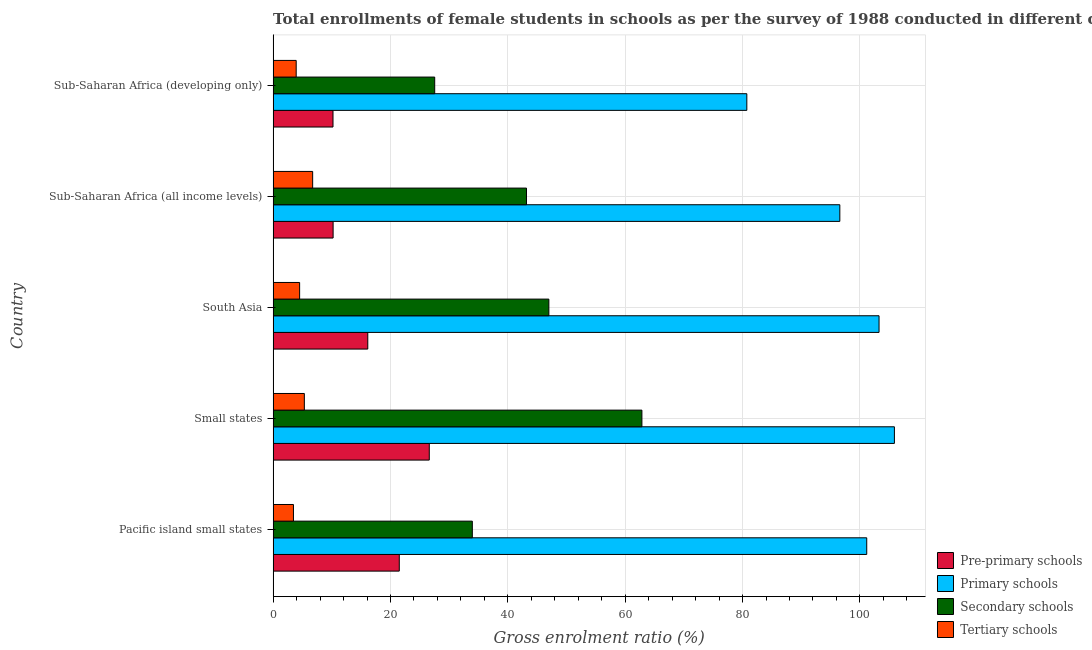How many groups of bars are there?
Your response must be concise. 5. Are the number of bars on each tick of the Y-axis equal?
Your answer should be compact. Yes. How many bars are there on the 3rd tick from the bottom?
Your answer should be compact. 4. What is the label of the 1st group of bars from the top?
Provide a succinct answer. Sub-Saharan Africa (developing only). In how many cases, is the number of bars for a given country not equal to the number of legend labels?
Provide a short and direct response. 0. What is the gross enrolment ratio(female) in secondary schools in Small states?
Your answer should be compact. 62.85. Across all countries, what is the maximum gross enrolment ratio(female) in primary schools?
Give a very brief answer. 105.88. Across all countries, what is the minimum gross enrolment ratio(female) in primary schools?
Provide a succinct answer. 80.73. In which country was the gross enrolment ratio(female) in primary schools maximum?
Your answer should be compact. Small states. In which country was the gross enrolment ratio(female) in tertiary schools minimum?
Make the answer very short. Pacific island small states. What is the total gross enrolment ratio(female) in secondary schools in the graph?
Give a very brief answer. 214.5. What is the difference between the gross enrolment ratio(female) in tertiary schools in Pacific island small states and that in South Asia?
Offer a terse response. -1.05. What is the difference between the gross enrolment ratio(female) in pre-primary schools in Small states and the gross enrolment ratio(female) in secondary schools in Sub-Saharan Africa (developing only)?
Offer a terse response. -0.92. What is the average gross enrolment ratio(female) in pre-primary schools per country?
Give a very brief answer. 16.93. What is the difference between the gross enrolment ratio(female) in pre-primary schools and gross enrolment ratio(female) in primary schools in South Asia?
Your response must be concise. -87.13. What is the ratio of the gross enrolment ratio(female) in pre-primary schools in Small states to that in South Asia?
Offer a very short reply. 1.65. Is the gross enrolment ratio(female) in primary schools in Small states less than that in Sub-Saharan Africa (all income levels)?
Your response must be concise. No. What is the difference between the highest and the second highest gross enrolment ratio(female) in primary schools?
Offer a terse response. 2.62. What is the difference between the highest and the lowest gross enrolment ratio(female) in secondary schools?
Provide a short and direct response. 35.31. In how many countries, is the gross enrolment ratio(female) in tertiary schools greater than the average gross enrolment ratio(female) in tertiary schools taken over all countries?
Keep it short and to the point. 2. Is it the case that in every country, the sum of the gross enrolment ratio(female) in pre-primary schools and gross enrolment ratio(female) in primary schools is greater than the sum of gross enrolment ratio(female) in secondary schools and gross enrolment ratio(female) in tertiary schools?
Provide a short and direct response. Yes. What does the 4th bar from the top in Sub-Saharan Africa (all income levels) represents?
Ensure brevity in your answer.  Pre-primary schools. What does the 1st bar from the bottom in Small states represents?
Offer a very short reply. Pre-primary schools. Is it the case that in every country, the sum of the gross enrolment ratio(female) in pre-primary schools and gross enrolment ratio(female) in primary schools is greater than the gross enrolment ratio(female) in secondary schools?
Ensure brevity in your answer.  Yes. Are all the bars in the graph horizontal?
Ensure brevity in your answer.  Yes. How many countries are there in the graph?
Ensure brevity in your answer.  5. What is the difference between two consecutive major ticks on the X-axis?
Your answer should be compact. 20. Are the values on the major ticks of X-axis written in scientific E-notation?
Keep it short and to the point. No. Where does the legend appear in the graph?
Make the answer very short. Bottom right. How many legend labels are there?
Provide a succinct answer. 4. What is the title of the graph?
Make the answer very short. Total enrollments of female students in schools as per the survey of 1988 conducted in different countries. Does "Management rating" appear as one of the legend labels in the graph?
Your response must be concise. No. What is the label or title of the Y-axis?
Your answer should be very brief. Country. What is the Gross enrolment ratio (%) of Pre-primary schools in Pacific island small states?
Your response must be concise. 21.5. What is the Gross enrolment ratio (%) of Primary schools in Pacific island small states?
Offer a terse response. 101.16. What is the Gross enrolment ratio (%) in Secondary schools in Pacific island small states?
Provide a short and direct response. 33.95. What is the Gross enrolment ratio (%) of Tertiary schools in Pacific island small states?
Your answer should be compact. 3.46. What is the Gross enrolment ratio (%) of Pre-primary schools in Small states?
Make the answer very short. 26.61. What is the Gross enrolment ratio (%) of Primary schools in Small states?
Make the answer very short. 105.88. What is the Gross enrolment ratio (%) in Secondary schools in Small states?
Your answer should be compact. 62.85. What is the Gross enrolment ratio (%) in Tertiary schools in Small states?
Make the answer very short. 5.32. What is the Gross enrolment ratio (%) in Pre-primary schools in South Asia?
Keep it short and to the point. 16.13. What is the Gross enrolment ratio (%) in Primary schools in South Asia?
Offer a very short reply. 103.26. What is the Gross enrolment ratio (%) in Secondary schools in South Asia?
Offer a terse response. 46.99. What is the Gross enrolment ratio (%) of Tertiary schools in South Asia?
Provide a succinct answer. 4.52. What is the Gross enrolment ratio (%) in Pre-primary schools in Sub-Saharan Africa (all income levels)?
Offer a very short reply. 10.22. What is the Gross enrolment ratio (%) of Primary schools in Sub-Saharan Africa (all income levels)?
Provide a short and direct response. 96.58. What is the Gross enrolment ratio (%) of Secondary schools in Sub-Saharan Africa (all income levels)?
Provide a short and direct response. 43.18. What is the Gross enrolment ratio (%) in Tertiary schools in Sub-Saharan Africa (all income levels)?
Provide a succinct answer. 6.74. What is the Gross enrolment ratio (%) in Pre-primary schools in Sub-Saharan Africa (developing only)?
Your answer should be compact. 10.21. What is the Gross enrolment ratio (%) in Primary schools in Sub-Saharan Africa (developing only)?
Your response must be concise. 80.73. What is the Gross enrolment ratio (%) of Secondary schools in Sub-Saharan Africa (developing only)?
Offer a very short reply. 27.54. What is the Gross enrolment ratio (%) of Tertiary schools in Sub-Saharan Africa (developing only)?
Keep it short and to the point. 3.93. Across all countries, what is the maximum Gross enrolment ratio (%) in Pre-primary schools?
Your answer should be very brief. 26.61. Across all countries, what is the maximum Gross enrolment ratio (%) of Primary schools?
Your answer should be very brief. 105.88. Across all countries, what is the maximum Gross enrolment ratio (%) in Secondary schools?
Your answer should be compact. 62.85. Across all countries, what is the maximum Gross enrolment ratio (%) in Tertiary schools?
Offer a very short reply. 6.74. Across all countries, what is the minimum Gross enrolment ratio (%) in Pre-primary schools?
Your response must be concise. 10.21. Across all countries, what is the minimum Gross enrolment ratio (%) of Primary schools?
Ensure brevity in your answer.  80.73. Across all countries, what is the minimum Gross enrolment ratio (%) in Secondary schools?
Provide a short and direct response. 27.54. Across all countries, what is the minimum Gross enrolment ratio (%) of Tertiary schools?
Provide a short and direct response. 3.46. What is the total Gross enrolment ratio (%) in Pre-primary schools in the graph?
Make the answer very short. 84.67. What is the total Gross enrolment ratio (%) of Primary schools in the graph?
Provide a short and direct response. 487.61. What is the total Gross enrolment ratio (%) in Secondary schools in the graph?
Keep it short and to the point. 214.5. What is the total Gross enrolment ratio (%) of Tertiary schools in the graph?
Offer a very short reply. 23.97. What is the difference between the Gross enrolment ratio (%) in Pre-primary schools in Pacific island small states and that in Small states?
Keep it short and to the point. -5.11. What is the difference between the Gross enrolment ratio (%) of Primary schools in Pacific island small states and that in Small states?
Ensure brevity in your answer.  -4.72. What is the difference between the Gross enrolment ratio (%) of Secondary schools in Pacific island small states and that in Small states?
Give a very brief answer. -28.9. What is the difference between the Gross enrolment ratio (%) in Tertiary schools in Pacific island small states and that in Small states?
Offer a very short reply. -1.86. What is the difference between the Gross enrolment ratio (%) in Pre-primary schools in Pacific island small states and that in South Asia?
Ensure brevity in your answer.  5.37. What is the difference between the Gross enrolment ratio (%) in Primary schools in Pacific island small states and that in South Asia?
Offer a terse response. -2.1. What is the difference between the Gross enrolment ratio (%) in Secondary schools in Pacific island small states and that in South Asia?
Your response must be concise. -13.04. What is the difference between the Gross enrolment ratio (%) of Tertiary schools in Pacific island small states and that in South Asia?
Offer a terse response. -1.05. What is the difference between the Gross enrolment ratio (%) of Pre-primary schools in Pacific island small states and that in Sub-Saharan Africa (all income levels)?
Your response must be concise. 11.28. What is the difference between the Gross enrolment ratio (%) of Primary schools in Pacific island small states and that in Sub-Saharan Africa (all income levels)?
Keep it short and to the point. 4.59. What is the difference between the Gross enrolment ratio (%) of Secondary schools in Pacific island small states and that in Sub-Saharan Africa (all income levels)?
Give a very brief answer. -9.23. What is the difference between the Gross enrolment ratio (%) in Tertiary schools in Pacific island small states and that in Sub-Saharan Africa (all income levels)?
Make the answer very short. -3.27. What is the difference between the Gross enrolment ratio (%) in Pre-primary schools in Pacific island small states and that in Sub-Saharan Africa (developing only)?
Give a very brief answer. 11.29. What is the difference between the Gross enrolment ratio (%) in Primary schools in Pacific island small states and that in Sub-Saharan Africa (developing only)?
Your response must be concise. 20.44. What is the difference between the Gross enrolment ratio (%) in Secondary schools in Pacific island small states and that in Sub-Saharan Africa (developing only)?
Your response must be concise. 6.41. What is the difference between the Gross enrolment ratio (%) in Tertiary schools in Pacific island small states and that in Sub-Saharan Africa (developing only)?
Offer a very short reply. -0.47. What is the difference between the Gross enrolment ratio (%) of Pre-primary schools in Small states and that in South Asia?
Provide a succinct answer. 10.48. What is the difference between the Gross enrolment ratio (%) in Primary schools in Small states and that in South Asia?
Keep it short and to the point. 2.62. What is the difference between the Gross enrolment ratio (%) in Secondary schools in Small states and that in South Asia?
Your response must be concise. 15.86. What is the difference between the Gross enrolment ratio (%) in Tertiary schools in Small states and that in South Asia?
Offer a terse response. 0.8. What is the difference between the Gross enrolment ratio (%) of Pre-primary schools in Small states and that in Sub-Saharan Africa (all income levels)?
Your response must be concise. 16.39. What is the difference between the Gross enrolment ratio (%) in Primary schools in Small states and that in Sub-Saharan Africa (all income levels)?
Your answer should be very brief. 9.3. What is the difference between the Gross enrolment ratio (%) of Secondary schools in Small states and that in Sub-Saharan Africa (all income levels)?
Provide a short and direct response. 19.67. What is the difference between the Gross enrolment ratio (%) of Tertiary schools in Small states and that in Sub-Saharan Africa (all income levels)?
Make the answer very short. -1.42. What is the difference between the Gross enrolment ratio (%) in Pre-primary schools in Small states and that in Sub-Saharan Africa (developing only)?
Your response must be concise. 16.41. What is the difference between the Gross enrolment ratio (%) in Primary schools in Small states and that in Sub-Saharan Africa (developing only)?
Ensure brevity in your answer.  25.15. What is the difference between the Gross enrolment ratio (%) in Secondary schools in Small states and that in Sub-Saharan Africa (developing only)?
Offer a terse response. 35.31. What is the difference between the Gross enrolment ratio (%) in Tertiary schools in Small states and that in Sub-Saharan Africa (developing only)?
Give a very brief answer. 1.39. What is the difference between the Gross enrolment ratio (%) of Pre-primary schools in South Asia and that in Sub-Saharan Africa (all income levels)?
Provide a short and direct response. 5.91. What is the difference between the Gross enrolment ratio (%) of Primary schools in South Asia and that in Sub-Saharan Africa (all income levels)?
Your answer should be very brief. 6.68. What is the difference between the Gross enrolment ratio (%) in Secondary schools in South Asia and that in Sub-Saharan Africa (all income levels)?
Your answer should be very brief. 3.81. What is the difference between the Gross enrolment ratio (%) in Tertiary schools in South Asia and that in Sub-Saharan Africa (all income levels)?
Keep it short and to the point. -2.22. What is the difference between the Gross enrolment ratio (%) of Pre-primary schools in South Asia and that in Sub-Saharan Africa (developing only)?
Give a very brief answer. 5.93. What is the difference between the Gross enrolment ratio (%) in Primary schools in South Asia and that in Sub-Saharan Africa (developing only)?
Provide a succinct answer. 22.53. What is the difference between the Gross enrolment ratio (%) of Secondary schools in South Asia and that in Sub-Saharan Africa (developing only)?
Your answer should be compact. 19.45. What is the difference between the Gross enrolment ratio (%) in Tertiary schools in South Asia and that in Sub-Saharan Africa (developing only)?
Ensure brevity in your answer.  0.59. What is the difference between the Gross enrolment ratio (%) of Pre-primary schools in Sub-Saharan Africa (all income levels) and that in Sub-Saharan Africa (developing only)?
Offer a very short reply. 0.02. What is the difference between the Gross enrolment ratio (%) of Primary schools in Sub-Saharan Africa (all income levels) and that in Sub-Saharan Africa (developing only)?
Your response must be concise. 15.85. What is the difference between the Gross enrolment ratio (%) of Secondary schools in Sub-Saharan Africa (all income levels) and that in Sub-Saharan Africa (developing only)?
Give a very brief answer. 15.64. What is the difference between the Gross enrolment ratio (%) of Tertiary schools in Sub-Saharan Africa (all income levels) and that in Sub-Saharan Africa (developing only)?
Your response must be concise. 2.81. What is the difference between the Gross enrolment ratio (%) in Pre-primary schools in Pacific island small states and the Gross enrolment ratio (%) in Primary schools in Small states?
Your answer should be very brief. -84.38. What is the difference between the Gross enrolment ratio (%) of Pre-primary schools in Pacific island small states and the Gross enrolment ratio (%) of Secondary schools in Small states?
Ensure brevity in your answer.  -41.35. What is the difference between the Gross enrolment ratio (%) in Pre-primary schools in Pacific island small states and the Gross enrolment ratio (%) in Tertiary schools in Small states?
Your response must be concise. 16.18. What is the difference between the Gross enrolment ratio (%) of Primary schools in Pacific island small states and the Gross enrolment ratio (%) of Secondary schools in Small states?
Your response must be concise. 38.32. What is the difference between the Gross enrolment ratio (%) of Primary schools in Pacific island small states and the Gross enrolment ratio (%) of Tertiary schools in Small states?
Give a very brief answer. 95.84. What is the difference between the Gross enrolment ratio (%) in Secondary schools in Pacific island small states and the Gross enrolment ratio (%) in Tertiary schools in Small states?
Keep it short and to the point. 28.63. What is the difference between the Gross enrolment ratio (%) of Pre-primary schools in Pacific island small states and the Gross enrolment ratio (%) of Primary schools in South Asia?
Give a very brief answer. -81.76. What is the difference between the Gross enrolment ratio (%) in Pre-primary schools in Pacific island small states and the Gross enrolment ratio (%) in Secondary schools in South Asia?
Offer a terse response. -25.49. What is the difference between the Gross enrolment ratio (%) of Pre-primary schools in Pacific island small states and the Gross enrolment ratio (%) of Tertiary schools in South Asia?
Your answer should be very brief. 16.98. What is the difference between the Gross enrolment ratio (%) of Primary schools in Pacific island small states and the Gross enrolment ratio (%) of Secondary schools in South Asia?
Keep it short and to the point. 54.17. What is the difference between the Gross enrolment ratio (%) in Primary schools in Pacific island small states and the Gross enrolment ratio (%) in Tertiary schools in South Asia?
Provide a succinct answer. 96.65. What is the difference between the Gross enrolment ratio (%) in Secondary schools in Pacific island small states and the Gross enrolment ratio (%) in Tertiary schools in South Asia?
Provide a short and direct response. 29.43. What is the difference between the Gross enrolment ratio (%) of Pre-primary schools in Pacific island small states and the Gross enrolment ratio (%) of Primary schools in Sub-Saharan Africa (all income levels)?
Provide a succinct answer. -75.08. What is the difference between the Gross enrolment ratio (%) in Pre-primary schools in Pacific island small states and the Gross enrolment ratio (%) in Secondary schools in Sub-Saharan Africa (all income levels)?
Offer a very short reply. -21.68. What is the difference between the Gross enrolment ratio (%) of Pre-primary schools in Pacific island small states and the Gross enrolment ratio (%) of Tertiary schools in Sub-Saharan Africa (all income levels)?
Offer a very short reply. 14.76. What is the difference between the Gross enrolment ratio (%) of Primary schools in Pacific island small states and the Gross enrolment ratio (%) of Secondary schools in Sub-Saharan Africa (all income levels)?
Offer a very short reply. 57.98. What is the difference between the Gross enrolment ratio (%) of Primary schools in Pacific island small states and the Gross enrolment ratio (%) of Tertiary schools in Sub-Saharan Africa (all income levels)?
Your answer should be very brief. 94.43. What is the difference between the Gross enrolment ratio (%) of Secondary schools in Pacific island small states and the Gross enrolment ratio (%) of Tertiary schools in Sub-Saharan Africa (all income levels)?
Give a very brief answer. 27.21. What is the difference between the Gross enrolment ratio (%) of Pre-primary schools in Pacific island small states and the Gross enrolment ratio (%) of Primary schools in Sub-Saharan Africa (developing only)?
Your answer should be compact. -59.23. What is the difference between the Gross enrolment ratio (%) of Pre-primary schools in Pacific island small states and the Gross enrolment ratio (%) of Secondary schools in Sub-Saharan Africa (developing only)?
Keep it short and to the point. -6.04. What is the difference between the Gross enrolment ratio (%) of Pre-primary schools in Pacific island small states and the Gross enrolment ratio (%) of Tertiary schools in Sub-Saharan Africa (developing only)?
Give a very brief answer. 17.57. What is the difference between the Gross enrolment ratio (%) of Primary schools in Pacific island small states and the Gross enrolment ratio (%) of Secondary schools in Sub-Saharan Africa (developing only)?
Make the answer very short. 73.63. What is the difference between the Gross enrolment ratio (%) of Primary schools in Pacific island small states and the Gross enrolment ratio (%) of Tertiary schools in Sub-Saharan Africa (developing only)?
Provide a succinct answer. 97.23. What is the difference between the Gross enrolment ratio (%) of Secondary schools in Pacific island small states and the Gross enrolment ratio (%) of Tertiary schools in Sub-Saharan Africa (developing only)?
Your response must be concise. 30.02. What is the difference between the Gross enrolment ratio (%) in Pre-primary schools in Small states and the Gross enrolment ratio (%) in Primary schools in South Asia?
Offer a very short reply. -76.65. What is the difference between the Gross enrolment ratio (%) in Pre-primary schools in Small states and the Gross enrolment ratio (%) in Secondary schools in South Asia?
Provide a short and direct response. -20.38. What is the difference between the Gross enrolment ratio (%) of Pre-primary schools in Small states and the Gross enrolment ratio (%) of Tertiary schools in South Asia?
Provide a succinct answer. 22.1. What is the difference between the Gross enrolment ratio (%) of Primary schools in Small states and the Gross enrolment ratio (%) of Secondary schools in South Asia?
Your response must be concise. 58.89. What is the difference between the Gross enrolment ratio (%) in Primary schools in Small states and the Gross enrolment ratio (%) in Tertiary schools in South Asia?
Offer a very short reply. 101.36. What is the difference between the Gross enrolment ratio (%) of Secondary schools in Small states and the Gross enrolment ratio (%) of Tertiary schools in South Asia?
Make the answer very short. 58.33. What is the difference between the Gross enrolment ratio (%) of Pre-primary schools in Small states and the Gross enrolment ratio (%) of Primary schools in Sub-Saharan Africa (all income levels)?
Offer a very short reply. -69.96. What is the difference between the Gross enrolment ratio (%) in Pre-primary schools in Small states and the Gross enrolment ratio (%) in Secondary schools in Sub-Saharan Africa (all income levels)?
Provide a succinct answer. -16.57. What is the difference between the Gross enrolment ratio (%) of Pre-primary schools in Small states and the Gross enrolment ratio (%) of Tertiary schools in Sub-Saharan Africa (all income levels)?
Your response must be concise. 19.88. What is the difference between the Gross enrolment ratio (%) in Primary schools in Small states and the Gross enrolment ratio (%) in Secondary schools in Sub-Saharan Africa (all income levels)?
Your response must be concise. 62.7. What is the difference between the Gross enrolment ratio (%) of Primary schools in Small states and the Gross enrolment ratio (%) of Tertiary schools in Sub-Saharan Africa (all income levels)?
Offer a terse response. 99.14. What is the difference between the Gross enrolment ratio (%) of Secondary schools in Small states and the Gross enrolment ratio (%) of Tertiary schools in Sub-Saharan Africa (all income levels)?
Make the answer very short. 56.11. What is the difference between the Gross enrolment ratio (%) in Pre-primary schools in Small states and the Gross enrolment ratio (%) in Primary schools in Sub-Saharan Africa (developing only)?
Make the answer very short. -54.12. What is the difference between the Gross enrolment ratio (%) in Pre-primary schools in Small states and the Gross enrolment ratio (%) in Secondary schools in Sub-Saharan Africa (developing only)?
Your response must be concise. -0.92. What is the difference between the Gross enrolment ratio (%) in Pre-primary schools in Small states and the Gross enrolment ratio (%) in Tertiary schools in Sub-Saharan Africa (developing only)?
Your answer should be compact. 22.68. What is the difference between the Gross enrolment ratio (%) in Primary schools in Small states and the Gross enrolment ratio (%) in Secondary schools in Sub-Saharan Africa (developing only)?
Your answer should be compact. 78.34. What is the difference between the Gross enrolment ratio (%) of Primary schools in Small states and the Gross enrolment ratio (%) of Tertiary schools in Sub-Saharan Africa (developing only)?
Provide a short and direct response. 101.95. What is the difference between the Gross enrolment ratio (%) of Secondary schools in Small states and the Gross enrolment ratio (%) of Tertiary schools in Sub-Saharan Africa (developing only)?
Provide a succinct answer. 58.92. What is the difference between the Gross enrolment ratio (%) of Pre-primary schools in South Asia and the Gross enrolment ratio (%) of Primary schools in Sub-Saharan Africa (all income levels)?
Your answer should be compact. -80.44. What is the difference between the Gross enrolment ratio (%) of Pre-primary schools in South Asia and the Gross enrolment ratio (%) of Secondary schools in Sub-Saharan Africa (all income levels)?
Ensure brevity in your answer.  -27.05. What is the difference between the Gross enrolment ratio (%) in Pre-primary schools in South Asia and the Gross enrolment ratio (%) in Tertiary schools in Sub-Saharan Africa (all income levels)?
Provide a short and direct response. 9.39. What is the difference between the Gross enrolment ratio (%) of Primary schools in South Asia and the Gross enrolment ratio (%) of Secondary schools in Sub-Saharan Africa (all income levels)?
Make the answer very short. 60.08. What is the difference between the Gross enrolment ratio (%) of Primary schools in South Asia and the Gross enrolment ratio (%) of Tertiary schools in Sub-Saharan Africa (all income levels)?
Offer a very short reply. 96.52. What is the difference between the Gross enrolment ratio (%) in Secondary schools in South Asia and the Gross enrolment ratio (%) in Tertiary schools in Sub-Saharan Africa (all income levels)?
Provide a succinct answer. 40.25. What is the difference between the Gross enrolment ratio (%) in Pre-primary schools in South Asia and the Gross enrolment ratio (%) in Primary schools in Sub-Saharan Africa (developing only)?
Your answer should be compact. -64.6. What is the difference between the Gross enrolment ratio (%) in Pre-primary schools in South Asia and the Gross enrolment ratio (%) in Secondary schools in Sub-Saharan Africa (developing only)?
Make the answer very short. -11.4. What is the difference between the Gross enrolment ratio (%) in Pre-primary schools in South Asia and the Gross enrolment ratio (%) in Tertiary schools in Sub-Saharan Africa (developing only)?
Keep it short and to the point. 12.2. What is the difference between the Gross enrolment ratio (%) of Primary schools in South Asia and the Gross enrolment ratio (%) of Secondary schools in Sub-Saharan Africa (developing only)?
Offer a terse response. 75.73. What is the difference between the Gross enrolment ratio (%) of Primary schools in South Asia and the Gross enrolment ratio (%) of Tertiary schools in Sub-Saharan Africa (developing only)?
Provide a short and direct response. 99.33. What is the difference between the Gross enrolment ratio (%) of Secondary schools in South Asia and the Gross enrolment ratio (%) of Tertiary schools in Sub-Saharan Africa (developing only)?
Give a very brief answer. 43.06. What is the difference between the Gross enrolment ratio (%) of Pre-primary schools in Sub-Saharan Africa (all income levels) and the Gross enrolment ratio (%) of Primary schools in Sub-Saharan Africa (developing only)?
Keep it short and to the point. -70.5. What is the difference between the Gross enrolment ratio (%) of Pre-primary schools in Sub-Saharan Africa (all income levels) and the Gross enrolment ratio (%) of Secondary schools in Sub-Saharan Africa (developing only)?
Your answer should be compact. -17.31. What is the difference between the Gross enrolment ratio (%) of Pre-primary schools in Sub-Saharan Africa (all income levels) and the Gross enrolment ratio (%) of Tertiary schools in Sub-Saharan Africa (developing only)?
Provide a succinct answer. 6.29. What is the difference between the Gross enrolment ratio (%) in Primary schools in Sub-Saharan Africa (all income levels) and the Gross enrolment ratio (%) in Secondary schools in Sub-Saharan Africa (developing only)?
Keep it short and to the point. 69.04. What is the difference between the Gross enrolment ratio (%) of Primary schools in Sub-Saharan Africa (all income levels) and the Gross enrolment ratio (%) of Tertiary schools in Sub-Saharan Africa (developing only)?
Your answer should be very brief. 92.65. What is the difference between the Gross enrolment ratio (%) of Secondary schools in Sub-Saharan Africa (all income levels) and the Gross enrolment ratio (%) of Tertiary schools in Sub-Saharan Africa (developing only)?
Offer a terse response. 39.25. What is the average Gross enrolment ratio (%) in Pre-primary schools per country?
Your answer should be compact. 16.93. What is the average Gross enrolment ratio (%) in Primary schools per country?
Offer a very short reply. 97.52. What is the average Gross enrolment ratio (%) in Secondary schools per country?
Your response must be concise. 42.9. What is the average Gross enrolment ratio (%) in Tertiary schools per country?
Give a very brief answer. 4.79. What is the difference between the Gross enrolment ratio (%) in Pre-primary schools and Gross enrolment ratio (%) in Primary schools in Pacific island small states?
Make the answer very short. -79.67. What is the difference between the Gross enrolment ratio (%) in Pre-primary schools and Gross enrolment ratio (%) in Secondary schools in Pacific island small states?
Your answer should be compact. -12.45. What is the difference between the Gross enrolment ratio (%) of Pre-primary schools and Gross enrolment ratio (%) of Tertiary schools in Pacific island small states?
Your answer should be compact. 18.04. What is the difference between the Gross enrolment ratio (%) in Primary schools and Gross enrolment ratio (%) in Secondary schools in Pacific island small states?
Ensure brevity in your answer.  67.22. What is the difference between the Gross enrolment ratio (%) in Primary schools and Gross enrolment ratio (%) in Tertiary schools in Pacific island small states?
Make the answer very short. 97.7. What is the difference between the Gross enrolment ratio (%) in Secondary schools and Gross enrolment ratio (%) in Tertiary schools in Pacific island small states?
Ensure brevity in your answer.  30.49. What is the difference between the Gross enrolment ratio (%) in Pre-primary schools and Gross enrolment ratio (%) in Primary schools in Small states?
Ensure brevity in your answer.  -79.27. What is the difference between the Gross enrolment ratio (%) of Pre-primary schools and Gross enrolment ratio (%) of Secondary schools in Small states?
Make the answer very short. -36.23. What is the difference between the Gross enrolment ratio (%) of Pre-primary schools and Gross enrolment ratio (%) of Tertiary schools in Small states?
Your answer should be compact. 21.29. What is the difference between the Gross enrolment ratio (%) of Primary schools and Gross enrolment ratio (%) of Secondary schools in Small states?
Your response must be concise. 43.03. What is the difference between the Gross enrolment ratio (%) of Primary schools and Gross enrolment ratio (%) of Tertiary schools in Small states?
Offer a very short reply. 100.56. What is the difference between the Gross enrolment ratio (%) of Secondary schools and Gross enrolment ratio (%) of Tertiary schools in Small states?
Make the answer very short. 57.53. What is the difference between the Gross enrolment ratio (%) of Pre-primary schools and Gross enrolment ratio (%) of Primary schools in South Asia?
Your answer should be compact. -87.13. What is the difference between the Gross enrolment ratio (%) of Pre-primary schools and Gross enrolment ratio (%) of Secondary schools in South Asia?
Provide a short and direct response. -30.86. What is the difference between the Gross enrolment ratio (%) in Pre-primary schools and Gross enrolment ratio (%) in Tertiary schools in South Asia?
Your response must be concise. 11.61. What is the difference between the Gross enrolment ratio (%) of Primary schools and Gross enrolment ratio (%) of Secondary schools in South Asia?
Make the answer very short. 56.27. What is the difference between the Gross enrolment ratio (%) in Primary schools and Gross enrolment ratio (%) in Tertiary schools in South Asia?
Your answer should be compact. 98.74. What is the difference between the Gross enrolment ratio (%) in Secondary schools and Gross enrolment ratio (%) in Tertiary schools in South Asia?
Provide a succinct answer. 42.47. What is the difference between the Gross enrolment ratio (%) in Pre-primary schools and Gross enrolment ratio (%) in Primary schools in Sub-Saharan Africa (all income levels)?
Your response must be concise. -86.35. What is the difference between the Gross enrolment ratio (%) in Pre-primary schools and Gross enrolment ratio (%) in Secondary schools in Sub-Saharan Africa (all income levels)?
Keep it short and to the point. -32.96. What is the difference between the Gross enrolment ratio (%) in Pre-primary schools and Gross enrolment ratio (%) in Tertiary schools in Sub-Saharan Africa (all income levels)?
Your response must be concise. 3.49. What is the difference between the Gross enrolment ratio (%) of Primary schools and Gross enrolment ratio (%) of Secondary schools in Sub-Saharan Africa (all income levels)?
Offer a very short reply. 53.4. What is the difference between the Gross enrolment ratio (%) of Primary schools and Gross enrolment ratio (%) of Tertiary schools in Sub-Saharan Africa (all income levels)?
Offer a very short reply. 89.84. What is the difference between the Gross enrolment ratio (%) of Secondary schools and Gross enrolment ratio (%) of Tertiary schools in Sub-Saharan Africa (all income levels)?
Your answer should be very brief. 36.44. What is the difference between the Gross enrolment ratio (%) in Pre-primary schools and Gross enrolment ratio (%) in Primary schools in Sub-Saharan Africa (developing only)?
Offer a terse response. -70.52. What is the difference between the Gross enrolment ratio (%) in Pre-primary schools and Gross enrolment ratio (%) in Secondary schools in Sub-Saharan Africa (developing only)?
Provide a short and direct response. -17.33. What is the difference between the Gross enrolment ratio (%) of Pre-primary schools and Gross enrolment ratio (%) of Tertiary schools in Sub-Saharan Africa (developing only)?
Provide a short and direct response. 6.27. What is the difference between the Gross enrolment ratio (%) of Primary schools and Gross enrolment ratio (%) of Secondary schools in Sub-Saharan Africa (developing only)?
Offer a very short reply. 53.19. What is the difference between the Gross enrolment ratio (%) of Primary schools and Gross enrolment ratio (%) of Tertiary schools in Sub-Saharan Africa (developing only)?
Your answer should be compact. 76.8. What is the difference between the Gross enrolment ratio (%) in Secondary schools and Gross enrolment ratio (%) in Tertiary schools in Sub-Saharan Africa (developing only)?
Keep it short and to the point. 23.6. What is the ratio of the Gross enrolment ratio (%) of Pre-primary schools in Pacific island small states to that in Small states?
Make the answer very short. 0.81. What is the ratio of the Gross enrolment ratio (%) in Primary schools in Pacific island small states to that in Small states?
Offer a terse response. 0.96. What is the ratio of the Gross enrolment ratio (%) of Secondary schools in Pacific island small states to that in Small states?
Ensure brevity in your answer.  0.54. What is the ratio of the Gross enrolment ratio (%) of Tertiary schools in Pacific island small states to that in Small states?
Offer a very short reply. 0.65. What is the ratio of the Gross enrolment ratio (%) of Pre-primary schools in Pacific island small states to that in South Asia?
Keep it short and to the point. 1.33. What is the ratio of the Gross enrolment ratio (%) of Primary schools in Pacific island small states to that in South Asia?
Offer a very short reply. 0.98. What is the ratio of the Gross enrolment ratio (%) in Secondary schools in Pacific island small states to that in South Asia?
Offer a terse response. 0.72. What is the ratio of the Gross enrolment ratio (%) of Tertiary schools in Pacific island small states to that in South Asia?
Your answer should be very brief. 0.77. What is the ratio of the Gross enrolment ratio (%) of Pre-primary schools in Pacific island small states to that in Sub-Saharan Africa (all income levels)?
Ensure brevity in your answer.  2.1. What is the ratio of the Gross enrolment ratio (%) of Primary schools in Pacific island small states to that in Sub-Saharan Africa (all income levels)?
Give a very brief answer. 1.05. What is the ratio of the Gross enrolment ratio (%) in Secondary schools in Pacific island small states to that in Sub-Saharan Africa (all income levels)?
Your answer should be very brief. 0.79. What is the ratio of the Gross enrolment ratio (%) of Tertiary schools in Pacific island small states to that in Sub-Saharan Africa (all income levels)?
Your answer should be compact. 0.51. What is the ratio of the Gross enrolment ratio (%) of Pre-primary schools in Pacific island small states to that in Sub-Saharan Africa (developing only)?
Offer a very short reply. 2.11. What is the ratio of the Gross enrolment ratio (%) of Primary schools in Pacific island small states to that in Sub-Saharan Africa (developing only)?
Offer a terse response. 1.25. What is the ratio of the Gross enrolment ratio (%) in Secondary schools in Pacific island small states to that in Sub-Saharan Africa (developing only)?
Make the answer very short. 1.23. What is the ratio of the Gross enrolment ratio (%) of Tertiary schools in Pacific island small states to that in Sub-Saharan Africa (developing only)?
Your response must be concise. 0.88. What is the ratio of the Gross enrolment ratio (%) of Pre-primary schools in Small states to that in South Asia?
Make the answer very short. 1.65. What is the ratio of the Gross enrolment ratio (%) of Primary schools in Small states to that in South Asia?
Offer a terse response. 1.03. What is the ratio of the Gross enrolment ratio (%) in Secondary schools in Small states to that in South Asia?
Keep it short and to the point. 1.34. What is the ratio of the Gross enrolment ratio (%) of Tertiary schools in Small states to that in South Asia?
Provide a succinct answer. 1.18. What is the ratio of the Gross enrolment ratio (%) of Pre-primary schools in Small states to that in Sub-Saharan Africa (all income levels)?
Keep it short and to the point. 2.6. What is the ratio of the Gross enrolment ratio (%) in Primary schools in Small states to that in Sub-Saharan Africa (all income levels)?
Keep it short and to the point. 1.1. What is the ratio of the Gross enrolment ratio (%) of Secondary schools in Small states to that in Sub-Saharan Africa (all income levels)?
Offer a very short reply. 1.46. What is the ratio of the Gross enrolment ratio (%) in Tertiary schools in Small states to that in Sub-Saharan Africa (all income levels)?
Your answer should be compact. 0.79. What is the ratio of the Gross enrolment ratio (%) in Pre-primary schools in Small states to that in Sub-Saharan Africa (developing only)?
Keep it short and to the point. 2.61. What is the ratio of the Gross enrolment ratio (%) in Primary schools in Small states to that in Sub-Saharan Africa (developing only)?
Your response must be concise. 1.31. What is the ratio of the Gross enrolment ratio (%) in Secondary schools in Small states to that in Sub-Saharan Africa (developing only)?
Your answer should be compact. 2.28. What is the ratio of the Gross enrolment ratio (%) in Tertiary schools in Small states to that in Sub-Saharan Africa (developing only)?
Provide a succinct answer. 1.35. What is the ratio of the Gross enrolment ratio (%) of Pre-primary schools in South Asia to that in Sub-Saharan Africa (all income levels)?
Your response must be concise. 1.58. What is the ratio of the Gross enrolment ratio (%) in Primary schools in South Asia to that in Sub-Saharan Africa (all income levels)?
Your answer should be very brief. 1.07. What is the ratio of the Gross enrolment ratio (%) of Secondary schools in South Asia to that in Sub-Saharan Africa (all income levels)?
Make the answer very short. 1.09. What is the ratio of the Gross enrolment ratio (%) of Tertiary schools in South Asia to that in Sub-Saharan Africa (all income levels)?
Provide a succinct answer. 0.67. What is the ratio of the Gross enrolment ratio (%) in Pre-primary schools in South Asia to that in Sub-Saharan Africa (developing only)?
Make the answer very short. 1.58. What is the ratio of the Gross enrolment ratio (%) of Primary schools in South Asia to that in Sub-Saharan Africa (developing only)?
Make the answer very short. 1.28. What is the ratio of the Gross enrolment ratio (%) in Secondary schools in South Asia to that in Sub-Saharan Africa (developing only)?
Provide a short and direct response. 1.71. What is the ratio of the Gross enrolment ratio (%) of Tertiary schools in South Asia to that in Sub-Saharan Africa (developing only)?
Provide a succinct answer. 1.15. What is the ratio of the Gross enrolment ratio (%) of Pre-primary schools in Sub-Saharan Africa (all income levels) to that in Sub-Saharan Africa (developing only)?
Provide a short and direct response. 1. What is the ratio of the Gross enrolment ratio (%) of Primary schools in Sub-Saharan Africa (all income levels) to that in Sub-Saharan Africa (developing only)?
Your answer should be very brief. 1.2. What is the ratio of the Gross enrolment ratio (%) of Secondary schools in Sub-Saharan Africa (all income levels) to that in Sub-Saharan Africa (developing only)?
Offer a terse response. 1.57. What is the ratio of the Gross enrolment ratio (%) in Tertiary schools in Sub-Saharan Africa (all income levels) to that in Sub-Saharan Africa (developing only)?
Provide a succinct answer. 1.71. What is the difference between the highest and the second highest Gross enrolment ratio (%) in Pre-primary schools?
Provide a succinct answer. 5.11. What is the difference between the highest and the second highest Gross enrolment ratio (%) in Primary schools?
Make the answer very short. 2.62. What is the difference between the highest and the second highest Gross enrolment ratio (%) in Secondary schools?
Provide a succinct answer. 15.86. What is the difference between the highest and the second highest Gross enrolment ratio (%) in Tertiary schools?
Offer a terse response. 1.42. What is the difference between the highest and the lowest Gross enrolment ratio (%) of Pre-primary schools?
Offer a very short reply. 16.41. What is the difference between the highest and the lowest Gross enrolment ratio (%) of Primary schools?
Your answer should be very brief. 25.15. What is the difference between the highest and the lowest Gross enrolment ratio (%) of Secondary schools?
Offer a very short reply. 35.31. What is the difference between the highest and the lowest Gross enrolment ratio (%) of Tertiary schools?
Your response must be concise. 3.27. 